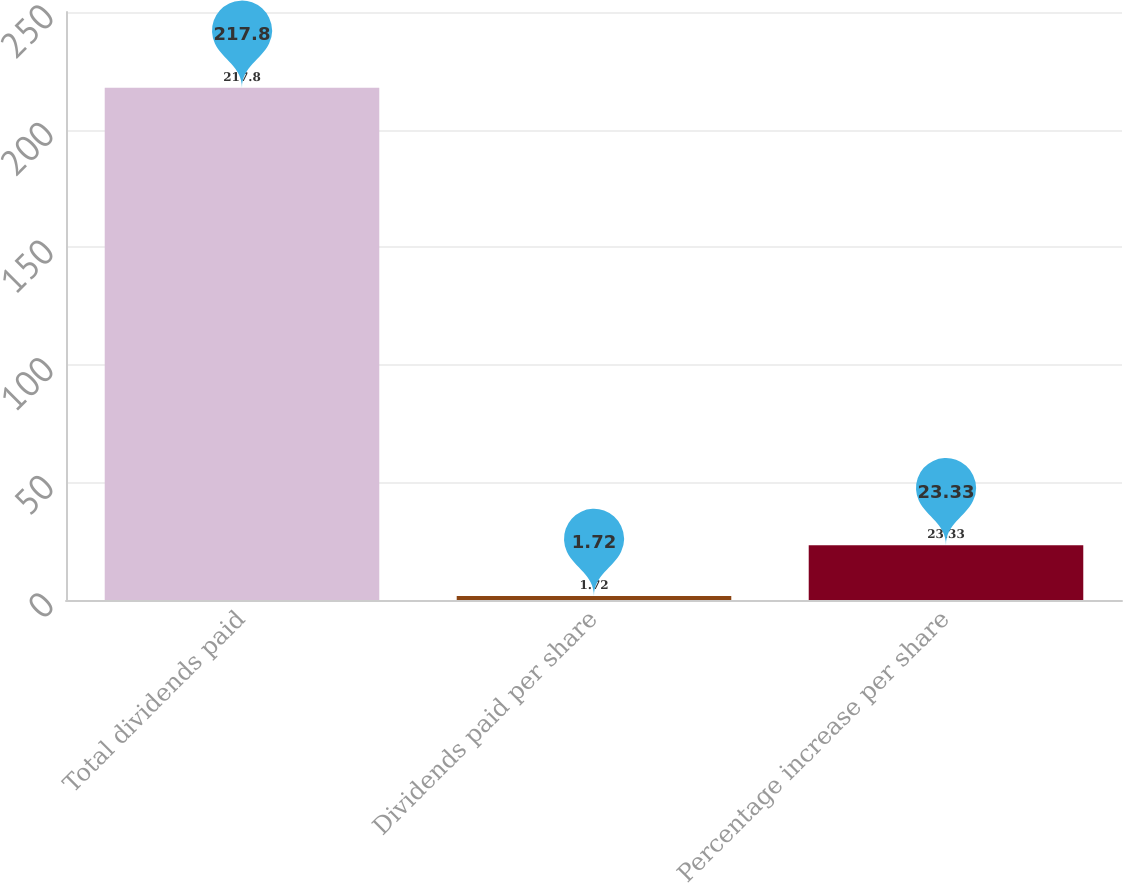Convert chart. <chart><loc_0><loc_0><loc_500><loc_500><bar_chart><fcel>Total dividends paid<fcel>Dividends paid per share<fcel>Percentage increase per share<nl><fcel>217.8<fcel>1.72<fcel>23.33<nl></chart> 